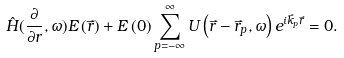<formula> <loc_0><loc_0><loc_500><loc_500>\hat { H } ( \frac { \partial } { \partial r } , \omega ) E \left ( \vec { r } \right ) + E \left ( 0 \right ) \sum _ { p = - \infty } ^ { \infty } U \left ( \vec { r } - \vec { r } _ { p } , \omega \right ) e ^ { i \vec { k } _ { p } \vec { r } } = 0 .</formula> 